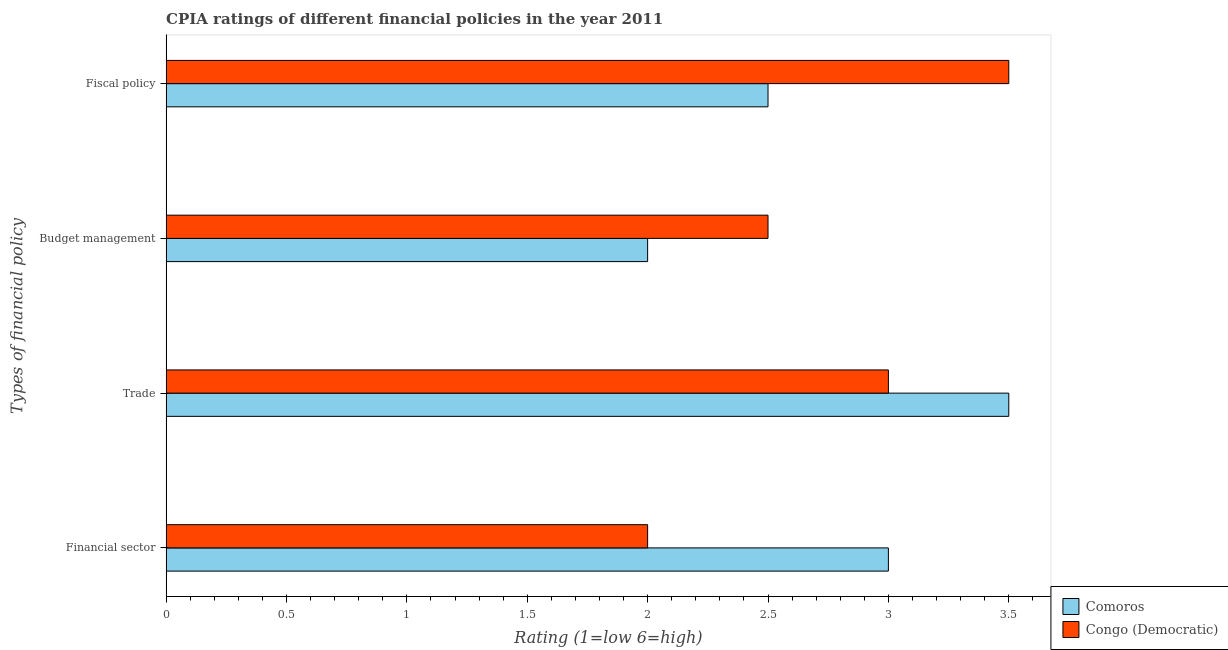Are the number of bars on each tick of the Y-axis equal?
Keep it short and to the point. Yes. How many bars are there on the 4th tick from the top?
Provide a succinct answer. 2. What is the label of the 4th group of bars from the top?
Offer a terse response. Financial sector. Across all countries, what is the minimum cpia rating of fiscal policy?
Your answer should be very brief. 2.5. In which country was the cpia rating of trade maximum?
Keep it short and to the point. Comoros. In which country was the cpia rating of trade minimum?
Keep it short and to the point. Congo (Democratic). What is the total cpia rating of budget management in the graph?
Provide a succinct answer. 4.5. What is the difference between the cpia rating of trade in Comoros and that in Congo (Democratic)?
Give a very brief answer. 0.5. What is the difference between the cpia rating of budget management in Congo (Democratic) and the cpia rating of trade in Comoros?
Your answer should be compact. -1. What is the average cpia rating of budget management per country?
Your answer should be compact. 2.25. What is the difference between the cpia rating of fiscal policy and cpia rating of budget management in Comoros?
Your answer should be compact. 0.5. In how many countries, is the cpia rating of financial sector greater than 1.2 ?
Offer a terse response. 2. What is the ratio of the cpia rating of financial sector in Congo (Democratic) to that in Comoros?
Give a very brief answer. 0.67. Is the cpia rating of budget management in Congo (Democratic) less than that in Comoros?
Your response must be concise. No. Is the difference between the cpia rating of fiscal policy in Comoros and Congo (Democratic) greater than the difference between the cpia rating of financial sector in Comoros and Congo (Democratic)?
Offer a terse response. No. What is the difference between the highest and the lowest cpia rating of financial sector?
Offer a terse response. 1. In how many countries, is the cpia rating of budget management greater than the average cpia rating of budget management taken over all countries?
Give a very brief answer. 1. Is it the case that in every country, the sum of the cpia rating of financial sector and cpia rating of trade is greater than the sum of cpia rating of fiscal policy and cpia rating of budget management?
Provide a short and direct response. No. What does the 2nd bar from the top in Fiscal policy represents?
Ensure brevity in your answer.  Comoros. What does the 2nd bar from the bottom in Trade represents?
Provide a short and direct response. Congo (Democratic). Is it the case that in every country, the sum of the cpia rating of financial sector and cpia rating of trade is greater than the cpia rating of budget management?
Provide a succinct answer. Yes. How many bars are there?
Offer a terse response. 8. Are all the bars in the graph horizontal?
Offer a very short reply. Yes. Does the graph contain grids?
Offer a very short reply. No. Where does the legend appear in the graph?
Provide a short and direct response. Bottom right. How many legend labels are there?
Give a very brief answer. 2. What is the title of the graph?
Keep it short and to the point. CPIA ratings of different financial policies in the year 2011. Does "Arab World" appear as one of the legend labels in the graph?
Your response must be concise. No. What is the label or title of the X-axis?
Your response must be concise. Rating (1=low 6=high). What is the label or title of the Y-axis?
Keep it short and to the point. Types of financial policy. What is the Rating (1=low 6=high) in Comoros in Budget management?
Provide a succinct answer. 2. What is the Rating (1=low 6=high) of Congo (Democratic) in Budget management?
Provide a succinct answer. 2.5. Across all Types of financial policy, what is the maximum Rating (1=low 6=high) in Congo (Democratic)?
Keep it short and to the point. 3.5. Across all Types of financial policy, what is the minimum Rating (1=low 6=high) of Comoros?
Your answer should be very brief. 2. Across all Types of financial policy, what is the minimum Rating (1=low 6=high) in Congo (Democratic)?
Offer a very short reply. 2. What is the total Rating (1=low 6=high) in Congo (Democratic) in the graph?
Make the answer very short. 11. What is the difference between the Rating (1=low 6=high) in Comoros in Financial sector and that in Trade?
Provide a succinct answer. -0.5. What is the difference between the Rating (1=low 6=high) in Congo (Democratic) in Financial sector and that in Trade?
Your response must be concise. -1. What is the difference between the Rating (1=low 6=high) of Comoros in Financial sector and that in Budget management?
Your answer should be compact. 1. What is the difference between the Rating (1=low 6=high) of Congo (Democratic) in Financial sector and that in Budget management?
Offer a very short reply. -0.5. What is the difference between the Rating (1=low 6=high) of Comoros in Financial sector and that in Fiscal policy?
Give a very brief answer. 0.5. What is the difference between the Rating (1=low 6=high) in Congo (Democratic) in Financial sector and that in Fiscal policy?
Ensure brevity in your answer.  -1.5. What is the difference between the Rating (1=low 6=high) of Comoros in Trade and that in Budget management?
Offer a very short reply. 1.5. What is the difference between the Rating (1=low 6=high) in Congo (Democratic) in Trade and that in Budget management?
Provide a short and direct response. 0.5. What is the difference between the Rating (1=low 6=high) of Comoros in Trade and that in Fiscal policy?
Ensure brevity in your answer.  1. What is the difference between the Rating (1=low 6=high) of Comoros in Budget management and that in Fiscal policy?
Ensure brevity in your answer.  -0.5. What is the difference between the Rating (1=low 6=high) of Comoros in Financial sector and the Rating (1=low 6=high) of Congo (Democratic) in Trade?
Offer a terse response. 0. What is the difference between the Rating (1=low 6=high) in Comoros in Financial sector and the Rating (1=low 6=high) in Congo (Democratic) in Budget management?
Provide a succinct answer. 0.5. What is the average Rating (1=low 6=high) in Comoros per Types of financial policy?
Make the answer very short. 2.75. What is the average Rating (1=low 6=high) of Congo (Democratic) per Types of financial policy?
Give a very brief answer. 2.75. What is the difference between the Rating (1=low 6=high) in Comoros and Rating (1=low 6=high) in Congo (Democratic) in Trade?
Give a very brief answer. 0.5. What is the ratio of the Rating (1=low 6=high) in Comoros in Financial sector to that in Budget management?
Your response must be concise. 1.5. What is the ratio of the Rating (1=low 6=high) in Congo (Democratic) in Financial sector to that in Budget management?
Your response must be concise. 0.8. What is the ratio of the Rating (1=low 6=high) of Congo (Democratic) in Financial sector to that in Fiscal policy?
Give a very brief answer. 0.57. What is the ratio of the Rating (1=low 6=high) of Comoros in Trade to that in Budget management?
Offer a very short reply. 1.75. What is the ratio of the Rating (1=low 6=high) of Comoros in Trade to that in Fiscal policy?
Your answer should be compact. 1.4. What is the ratio of the Rating (1=low 6=high) in Comoros in Budget management to that in Fiscal policy?
Your response must be concise. 0.8. What is the difference between the highest and the second highest Rating (1=low 6=high) of Comoros?
Offer a very short reply. 0.5. What is the difference between the highest and the second highest Rating (1=low 6=high) in Congo (Democratic)?
Keep it short and to the point. 0.5. What is the difference between the highest and the lowest Rating (1=low 6=high) in Comoros?
Ensure brevity in your answer.  1.5. What is the difference between the highest and the lowest Rating (1=low 6=high) of Congo (Democratic)?
Keep it short and to the point. 1.5. 